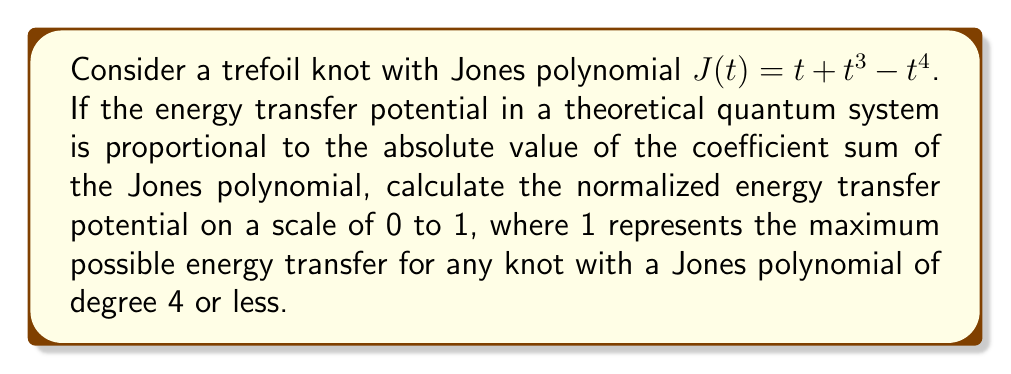What is the answer to this math problem? 1) First, let's identify the coefficients of the Jones polynomial:
   $J(t) = t + t^3 - t^4 = 0 + 1t + 0t^2 + 1t^3 - 1t^4$
   Coefficients: [0, 1, 0, 1, -1]

2) Calculate the sum of the absolute values of the coefficients:
   $|0| + |1| + |0| + |1| + |-1| = 0 + 1 + 0 + 1 + 1 = 3$

3) To normalize this value, we need to consider the maximum possible sum for any knot with a Jones polynomial of degree 4 or less. The maximum would occur when all coefficients have an absolute value of 1:
   Maximum sum = $|±1| + |±1| + |±1| + |±1| + |±1| = 5$

4) Calculate the normalized energy transfer potential:
   $$\text{Normalized Potential} = \frac{\text{Actual Sum}}{\text{Maximum Sum}} = \frac{3}{5} = 0.6$$

Therefore, the normalized energy transfer potential for this trefoil knot is 0.6 on a scale of 0 to 1.
Answer: 0.6 